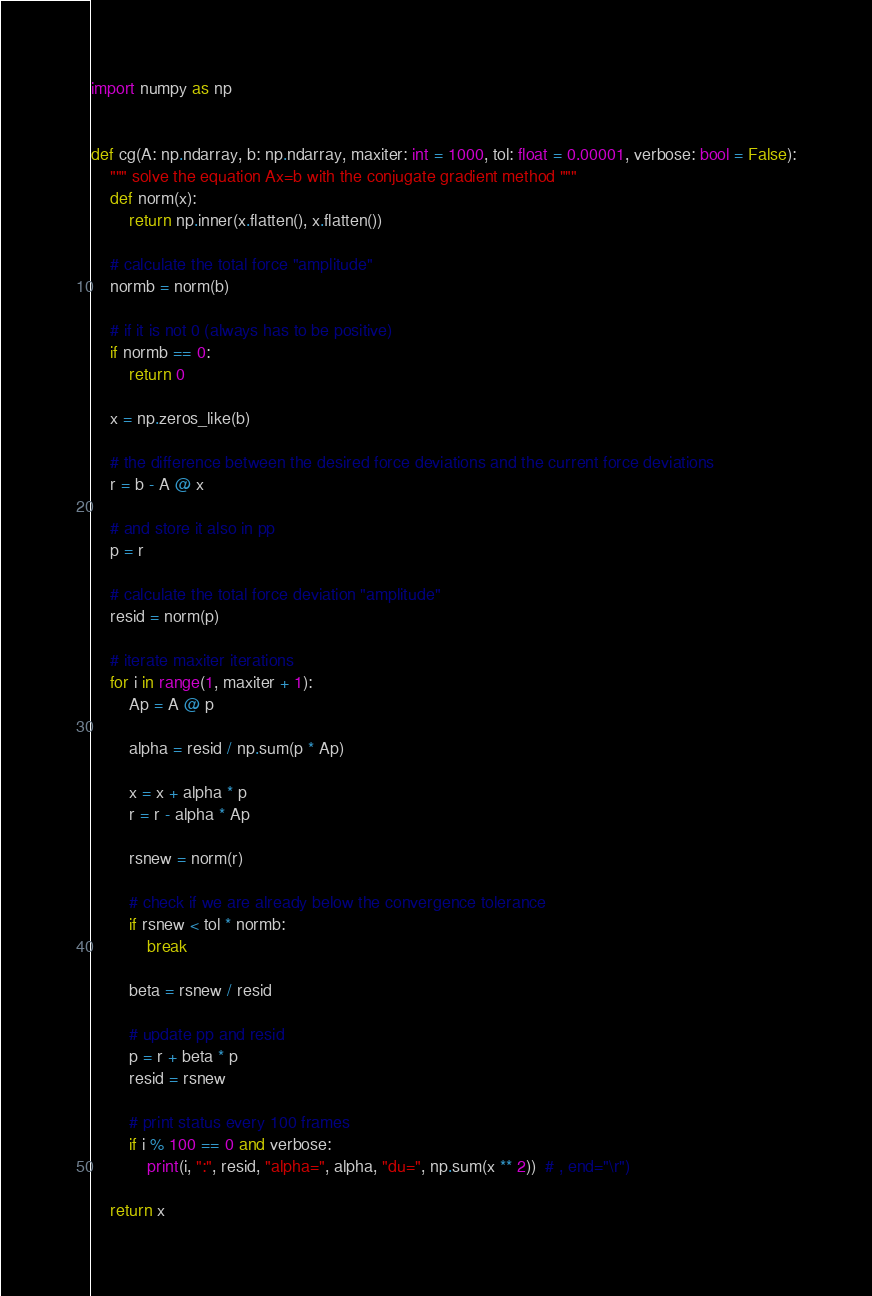<code> <loc_0><loc_0><loc_500><loc_500><_Python_>import numpy as np


def cg(A: np.ndarray, b: np.ndarray, maxiter: int = 1000, tol: float = 0.00001, verbose: bool = False):
    """ solve the equation Ax=b with the conjugate gradient method """
    def norm(x):
        return np.inner(x.flatten(), x.flatten())

    # calculate the total force "amplitude"
    normb = norm(b)

    # if it is not 0 (always has to be positive)
    if normb == 0:
        return 0

    x = np.zeros_like(b)

    # the difference between the desired force deviations and the current force deviations
    r = b - A @ x

    # and store it also in pp
    p = r

    # calculate the total force deviation "amplitude"
    resid = norm(p)

    # iterate maxiter iterations
    for i in range(1, maxiter + 1):
        Ap = A @ p

        alpha = resid / np.sum(p * Ap)

        x = x + alpha * p
        r = r - alpha * Ap

        rsnew = norm(r)

        # check if we are already below the convergence tolerance
        if rsnew < tol * normb:
            break

        beta = rsnew / resid

        # update pp and resid
        p = r + beta * p
        resid = rsnew

        # print status every 100 frames
        if i % 100 == 0 and verbose:
            print(i, ":", resid, "alpha=", alpha, "du=", np.sum(x ** 2))  # , end="\r")

    return x</code> 